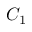<formula> <loc_0><loc_0><loc_500><loc_500>C _ { 1 }</formula> 